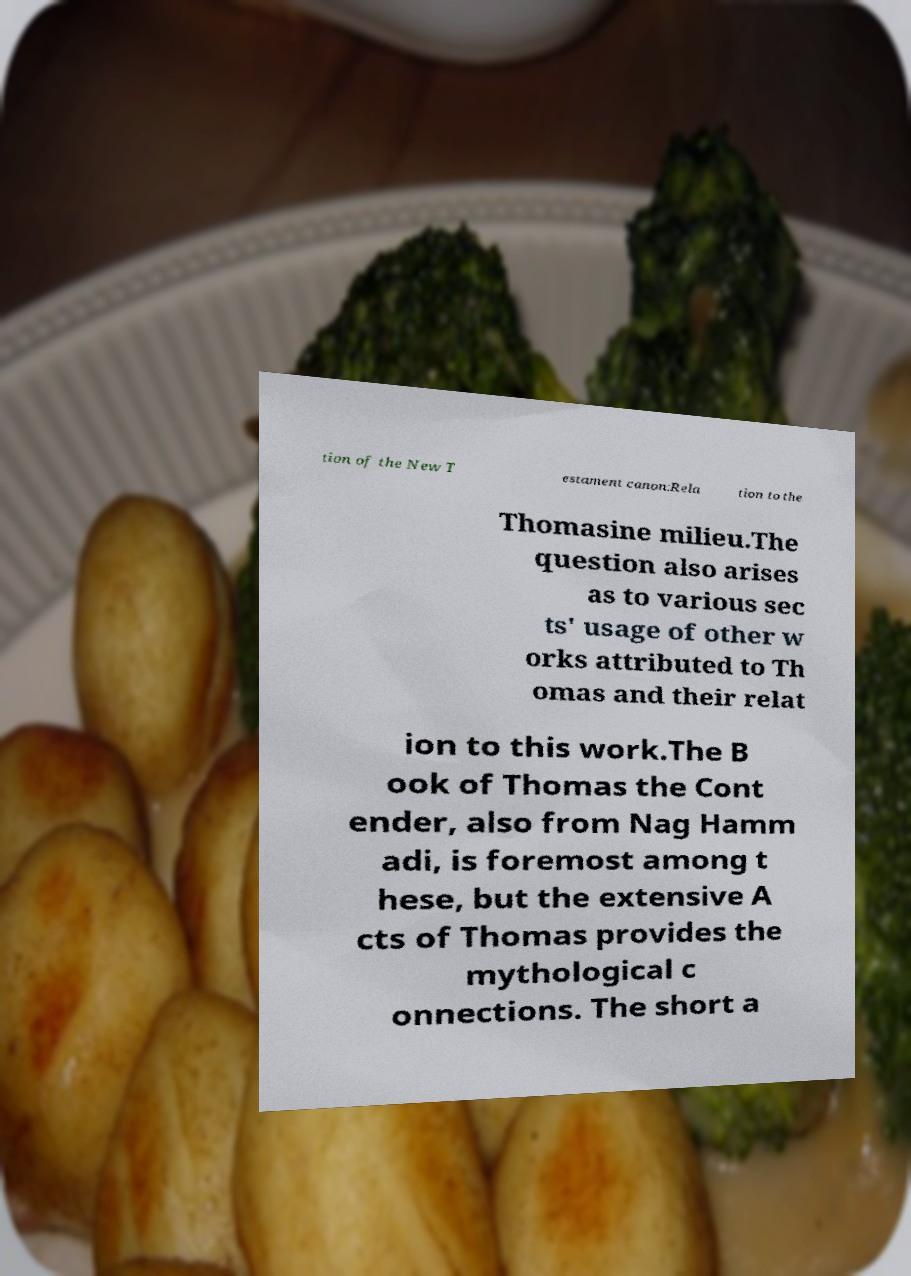Can you read and provide the text displayed in the image?This photo seems to have some interesting text. Can you extract and type it out for me? tion of the New T estament canon:Rela tion to the Thomasine milieu.The question also arises as to various sec ts' usage of other w orks attributed to Th omas and their relat ion to this work.The B ook of Thomas the Cont ender, also from Nag Hamm adi, is foremost among t hese, but the extensive A cts of Thomas provides the mythological c onnections. The short a 